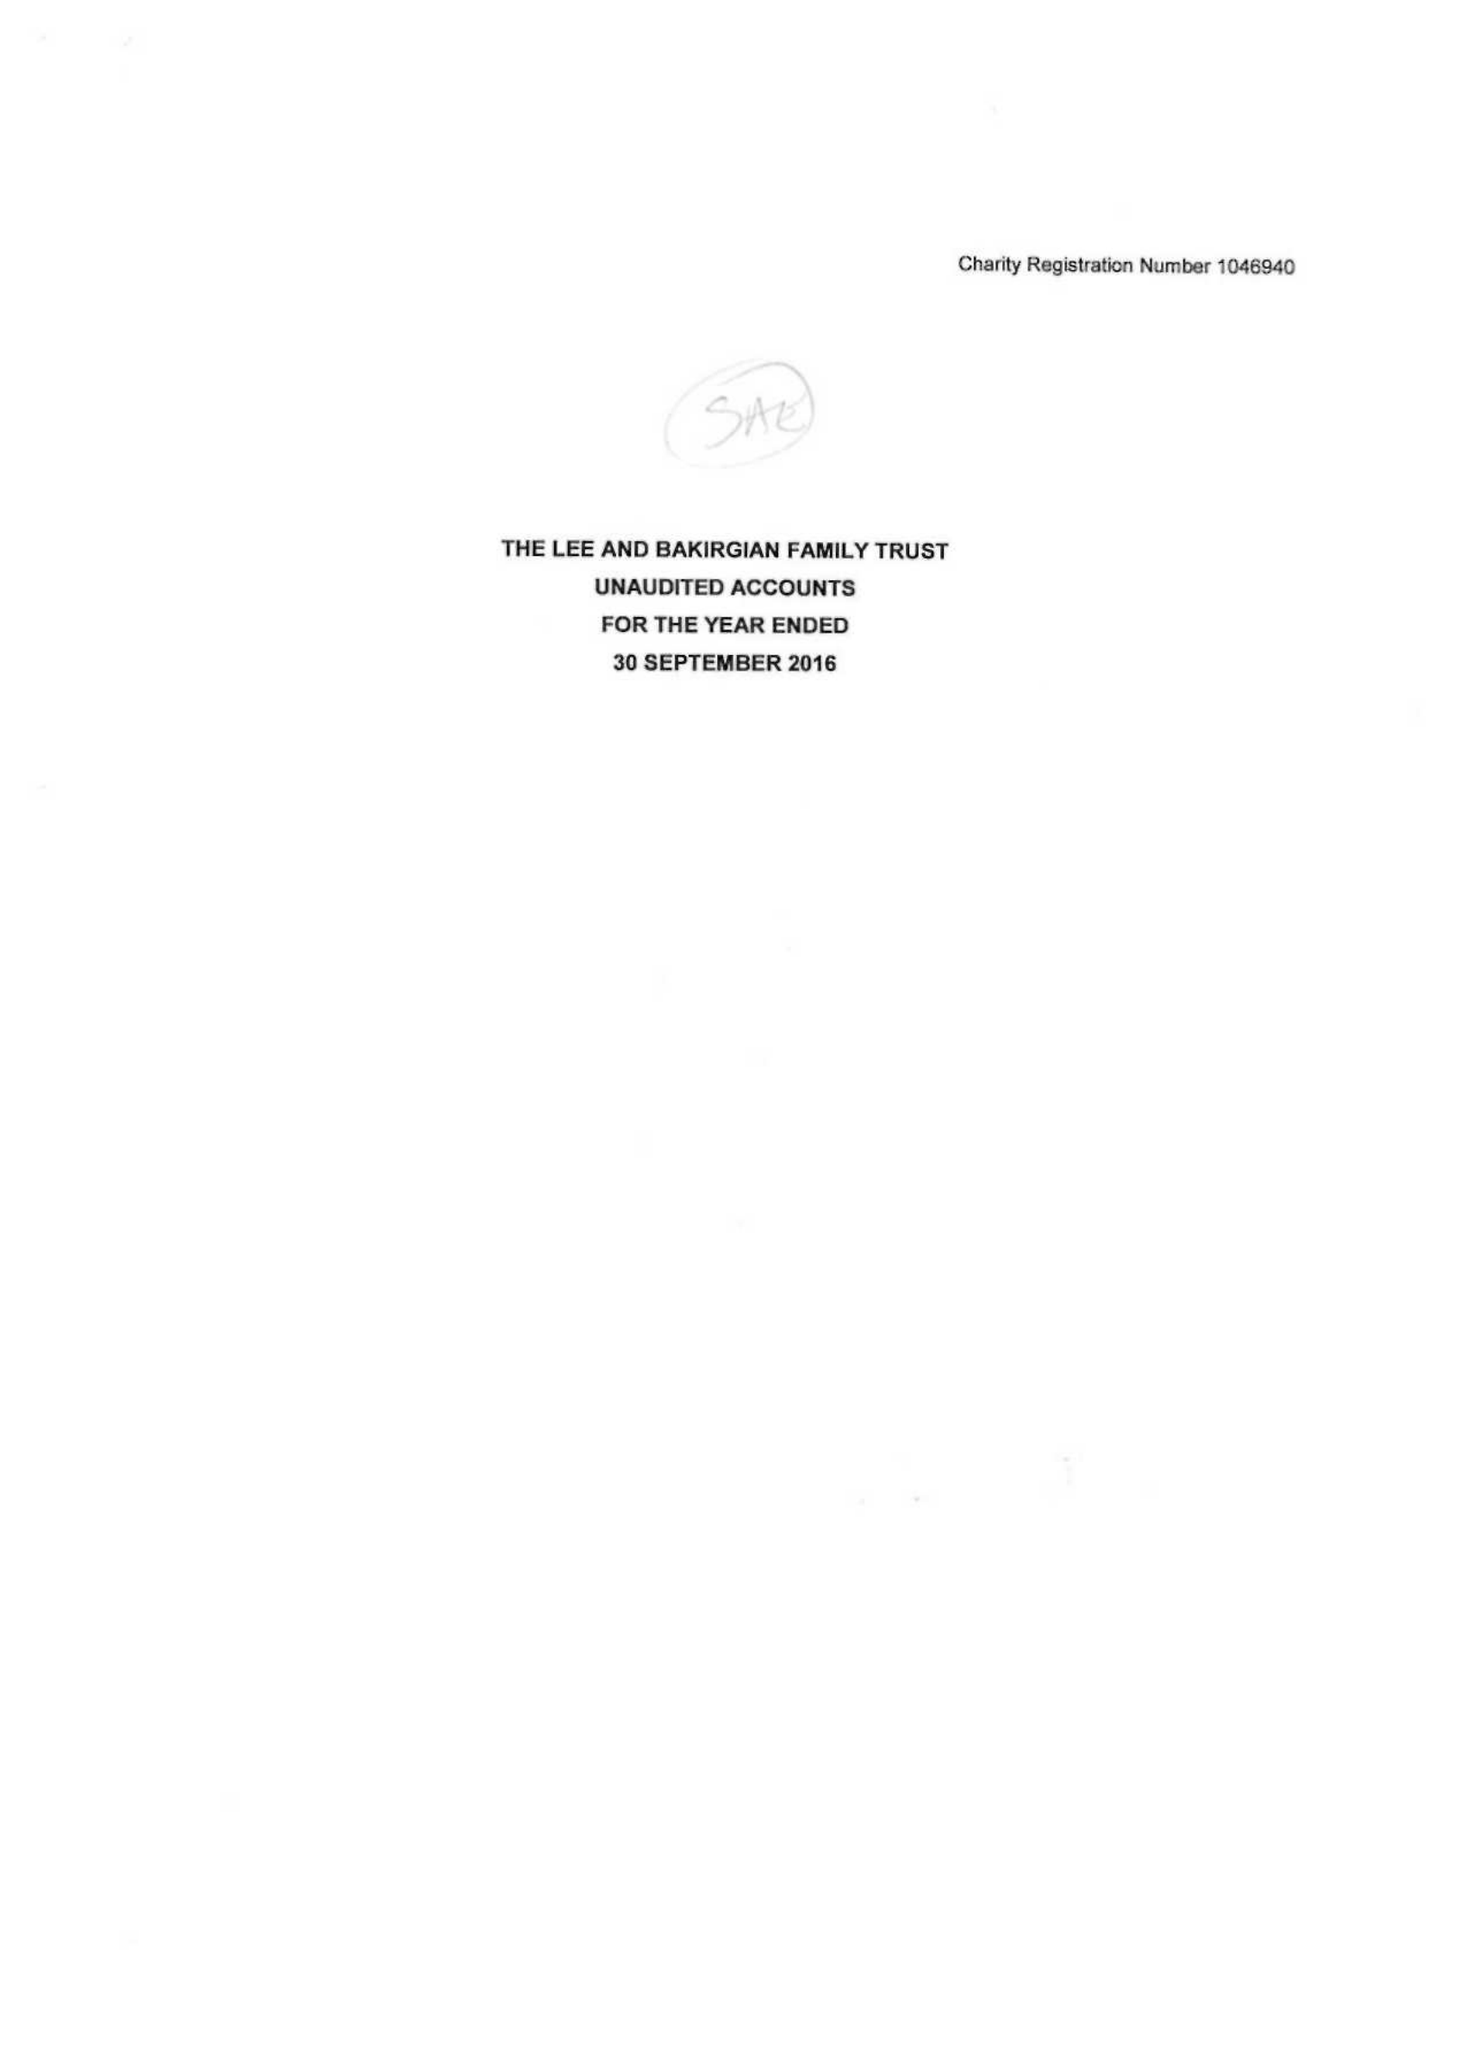What is the value for the spending_annually_in_british_pounds?
Answer the question using a single word or phrase. 20466.00 